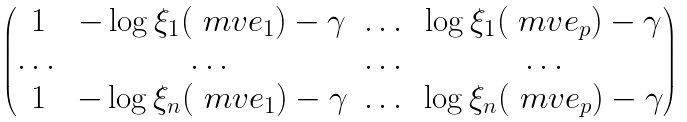<formula> <loc_0><loc_0><loc_500><loc_500>\begin{pmatrix} 1 & - \log \xi _ { 1 } ( \ m v { e } _ { 1 } ) - \gamma & \dots & \log \xi _ { 1 } ( \ m v { e } _ { p } ) - \gamma \\ \dots & \dots & \dots & \dots \\ 1 & - \log \xi _ { n } ( \ m v { e } _ { 1 } ) - \gamma & \dots & \log \xi _ { n } ( \ m v { e } _ { p } ) - \gamma \end{pmatrix}</formula> 